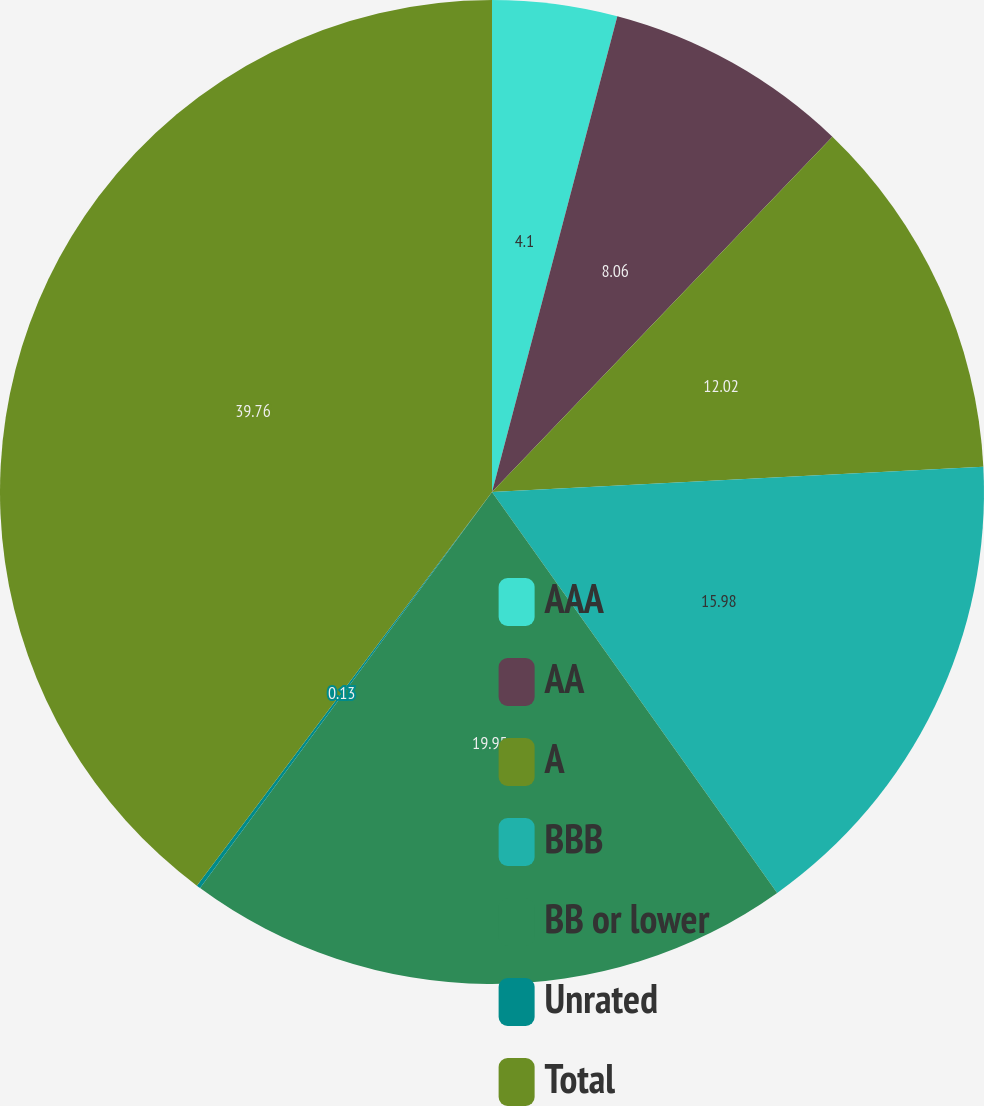<chart> <loc_0><loc_0><loc_500><loc_500><pie_chart><fcel>AAA<fcel>AA<fcel>A<fcel>BBB<fcel>BB or lower<fcel>Unrated<fcel>Total<nl><fcel>4.1%<fcel>8.06%<fcel>12.02%<fcel>15.98%<fcel>19.95%<fcel>0.13%<fcel>39.76%<nl></chart> 